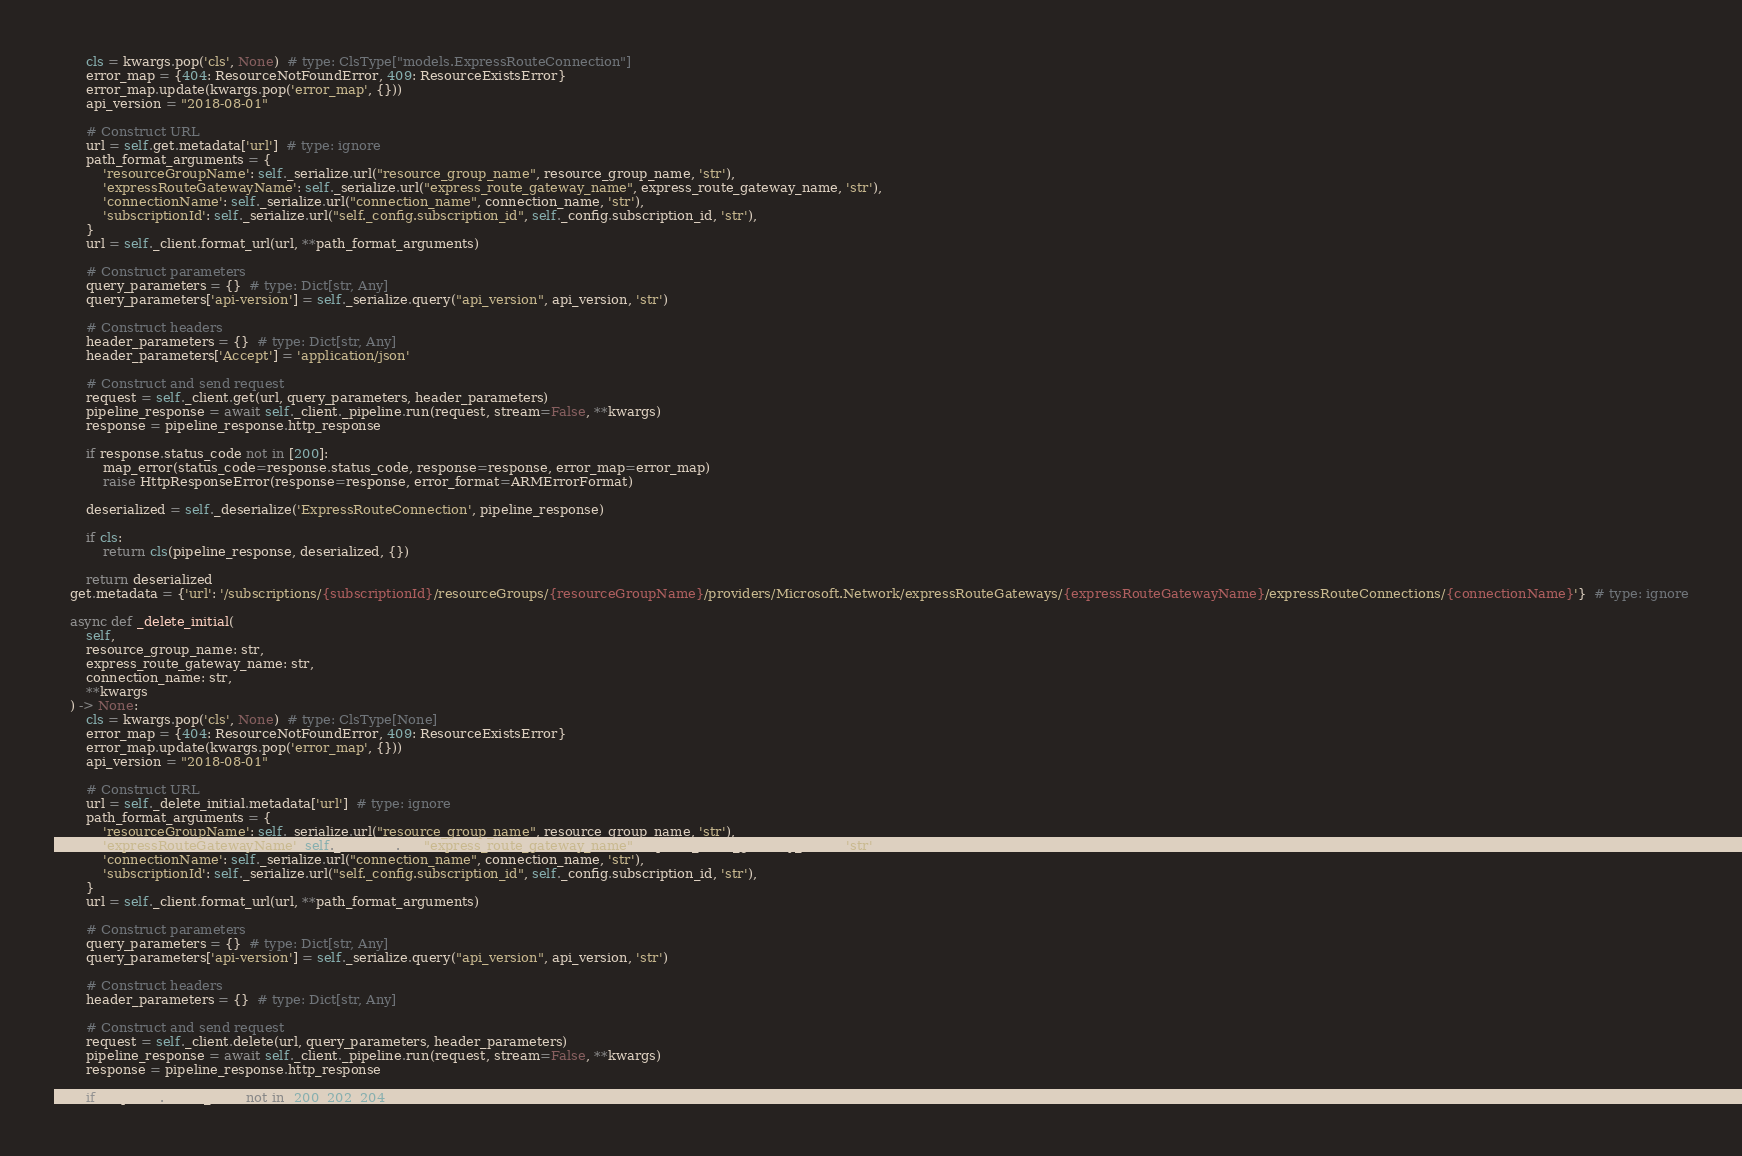Convert code to text. <code><loc_0><loc_0><loc_500><loc_500><_Python_>        cls = kwargs.pop('cls', None)  # type: ClsType["models.ExpressRouteConnection"]
        error_map = {404: ResourceNotFoundError, 409: ResourceExistsError}
        error_map.update(kwargs.pop('error_map', {}))
        api_version = "2018-08-01"

        # Construct URL
        url = self.get.metadata['url']  # type: ignore
        path_format_arguments = {
            'resourceGroupName': self._serialize.url("resource_group_name", resource_group_name, 'str'),
            'expressRouteGatewayName': self._serialize.url("express_route_gateway_name", express_route_gateway_name, 'str'),
            'connectionName': self._serialize.url("connection_name", connection_name, 'str'),
            'subscriptionId': self._serialize.url("self._config.subscription_id", self._config.subscription_id, 'str'),
        }
        url = self._client.format_url(url, **path_format_arguments)

        # Construct parameters
        query_parameters = {}  # type: Dict[str, Any]
        query_parameters['api-version'] = self._serialize.query("api_version", api_version, 'str')

        # Construct headers
        header_parameters = {}  # type: Dict[str, Any]
        header_parameters['Accept'] = 'application/json'

        # Construct and send request
        request = self._client.get(url, query_parameters, header_parameters)
        pipeline_response = await self._client._pipeline.run(request, stream=False, **kwargs)
        response = pipeline_response.http_response

        if response.status_code not in [200]:
            map_error(status_code=response.status_code, response=response, error_map=error_map)
            raise HttpResponseError(response=response, error_format=ARMErrorFormat)

        deserialized = self._deserialize('ExpressRouteConnection', pipeline_response)

        if cls:
            return cls(pipeline_response, deserialized, {})

        return deserialized
    get.metadata = {'url': '/subscriptions/{subscriptionId}/resourceGroups/{resourceGroupName}/providers/Microsoft.Network/expressRouteGateways/{expressRouteGatewayName}/expressRouteConnections/{connectionName}'}  # type: ignore

    async def _delete_initial(
        self,
        resource_group_name: str,
        express_route_gateway_name: str,
        connection_name: str,
        **kwargs
    ) -> None:
        cls = kwargs.pop('cls', None)  # type: ClsType[None]
        error_map = {404: ResourceNotFoundError, 409: ResourceExistsError}
        error_map.update(kwargs.pop('error_map', {}))
        api_version = "2018-08-01"

        # Construct URL
        url = self._delete_initial.metadata['url']  # type: ignore
        path_format_arguments = {
            'resourceGroupName': self._serialize.url("resource_group_name", resource_group_name, 'str'),
            'expressRouteGatewayName': self._serialize.url("express_route_gateway_name", express_route_gateway_name, 'str'),
            'connectionName': self._serialize.url("connection_name", connection_name, 'str'),
            'subscriptionId': self._serialize.url("self._config.subscription_id", self._config.subscription_id, 'str'),
        }
        url = self._client.format_url(url, **path_format_arguments)

        # Construct parameters
        query_parameters = {}  # type: Dict[str, Any]
        query_parameters['api-version'] = self._serialize.query("api_version", api_version, 'str')

        # Construct headers
        header_parameters = {}  # type: Dict[str, Any]

        # Construct and send request
        request = self._client.delete(url, query_parameters, header_parameters)
        pipeline_response = await self._client._pipeline.run(request, stream=False, **kwargs)
        response = pipeline_response.http_response

        if response.status_code not in [200, 202, 204]:</code> 